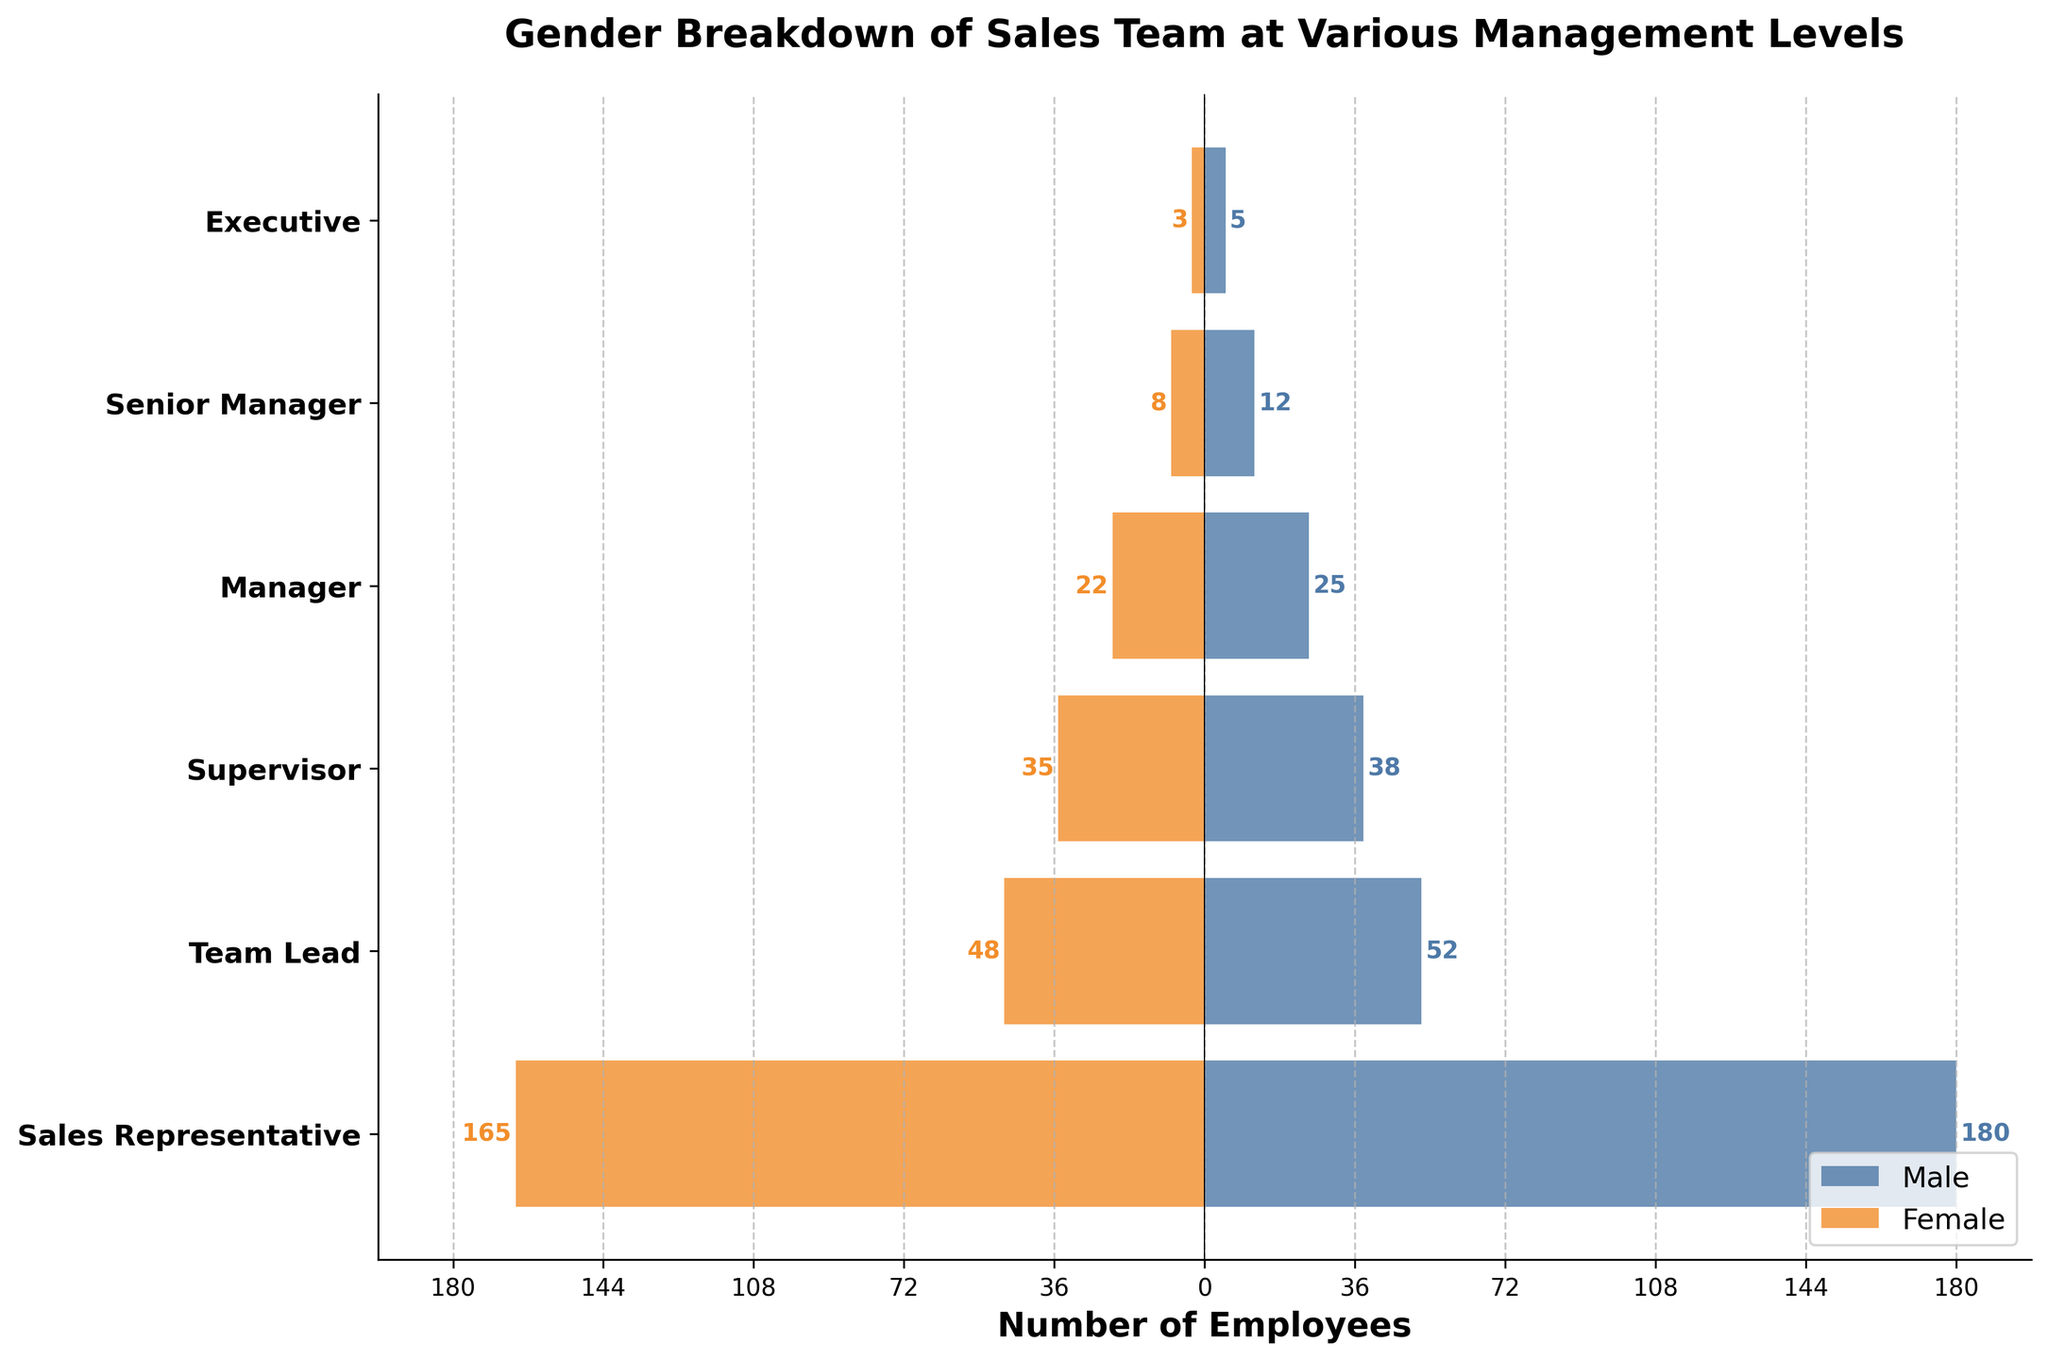What's the title of the figure? The title is found at the top of the figure and provides a description of the visualization.
Answer: Gender Breakdown of Sales Team at Various Management Levels What are the colors representing male and female employees? The colors used in the bars differentiate between male and female employees. The male employees are represented by a blue color, while the female employees are represented by an orange color.
Answer: Blue for male, Orange for female What's the total number of male and female executives? By looking at the bars corresponding to the "Executive" level, we see 5 males and 3 females. Adding these numbers gives the total.
Answer: 8 Which management level has the highest number of female employees? By comparing the lengths of the bars representing female employees at different levels, the longest bar is for the "Sales Representative" level, indicating it has the highest number of female employees.
Answer: Sales Representative How many more male Team Leads are there compared to female Team Leads? The number of male Team Leads is 52 and the number of female Team Leads is 48. Subtracting these numbers gives the difference.
Answer: 4 What's the combined total number of sales team members at the Manager level? Adding the number of male (25) and female (22) employees at the "Manager" level gives the combined total.
Answer: 47 Which management level has a nearly equal number of male and female employees? By examining the lengths of the bars, the "Supervisor" level shows a nearly equal distribution with 38 males and 35 females.
Answer: Supervisor What is the difference in the number of male and female Senior Managers? The number of male Senior Managers is 12 and the number of female Senior Managers is 8. Subtracting these numbers gives the difference.
Answer: 4 Which management level has the smallest number of employees? The bars representing the number of employees at the "Executive" level are the shortest among all levels, indicating the smallest number of employees.
Answer: Executive 